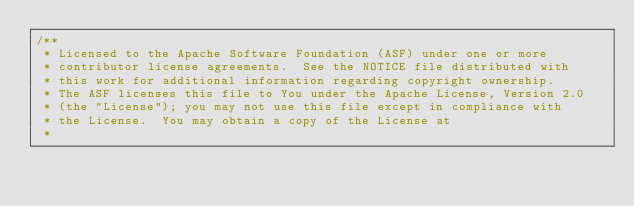<code> <loc_0><loc_0><loc_500><loc_500><_Java_>/**
 * Licensed to the Apache Software Foundation (ASF) under one or more
 * contributor license agreements.  See the NOTICE file distributed with
 * this work for additional information regarding copyright ownership.
 * The ASF licenses this file to You under the Apache License, Version 2.0
 * (the "License"); you may not use this file except in compliance with
 * the License.  You may obtain a copy of the License at
 *</code> 